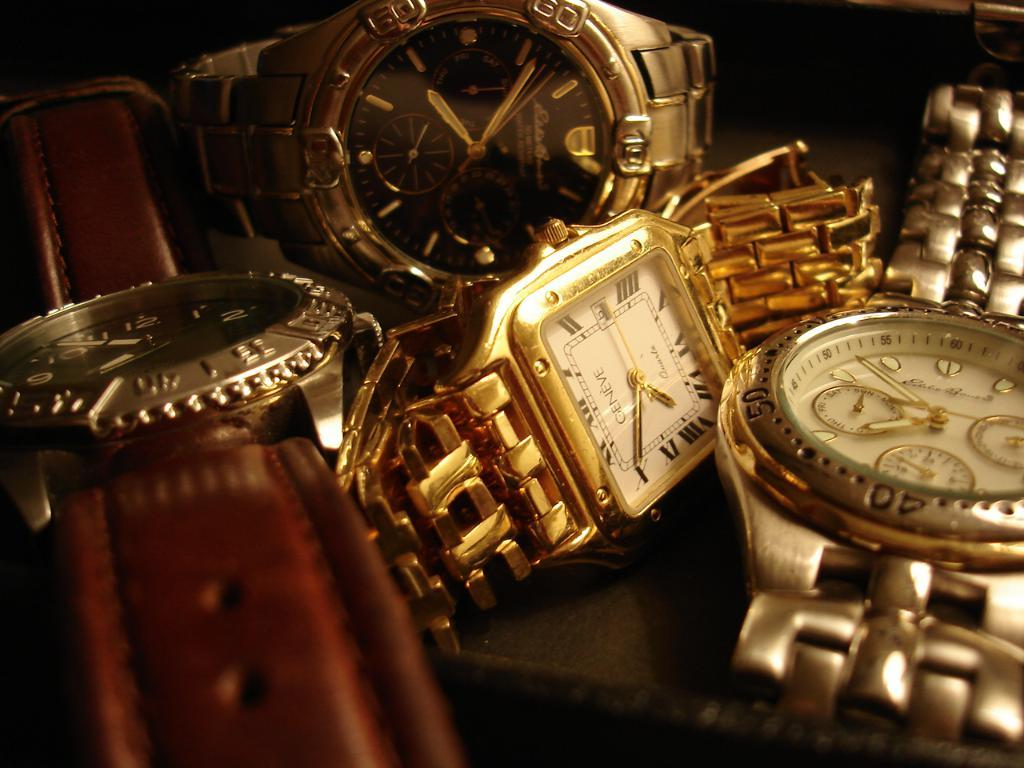<image>
Render a clear and concise summary of the photo. group of wristwatches including ones made by geneve and eddie bauer 